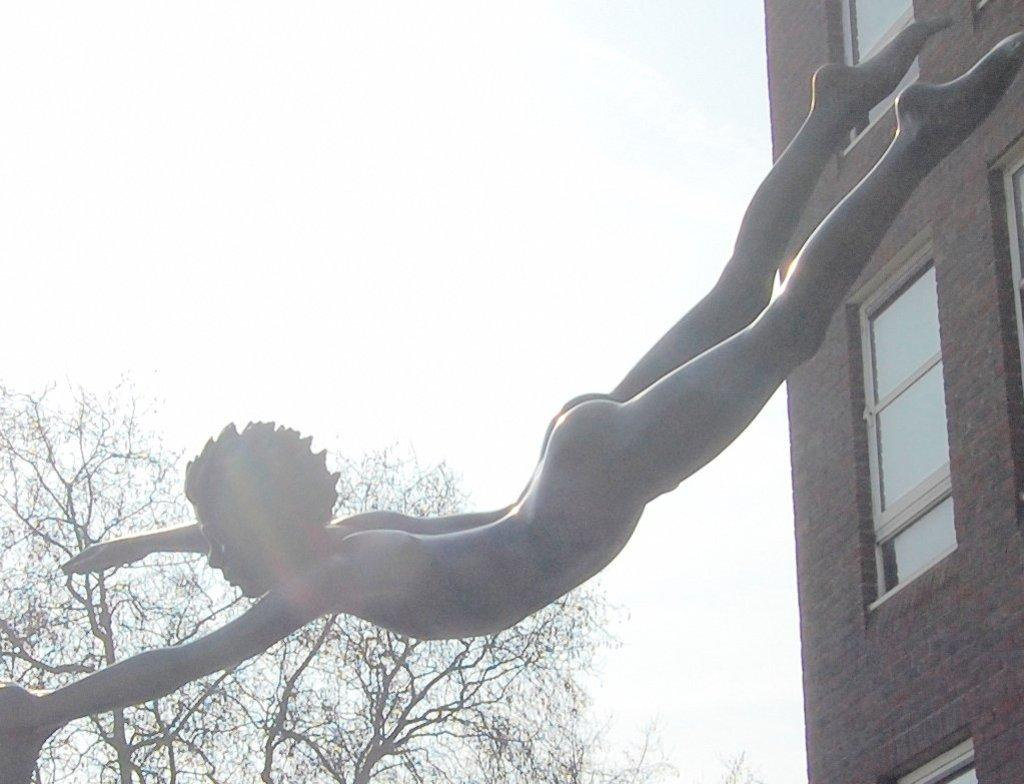What can be seen in the background of the image? There is a sky and a tree visible in the background of the image. What is the main subject of the image? There is a sculpture in the image. What type of structure is present in the image? There is a building in the image. What architectural feature can be seen on the building? There are windows in the image. How many jellyfish are sitting on the chair in the image? There are no jellyfish or chairs present in the image. 